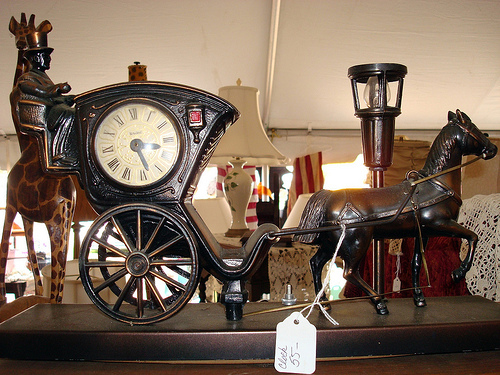<image>
Is the wall behind the horse? Yes. From this viewpoint, the wall is positioned behind the horse, with the horse partially or fully occluding the wall. 